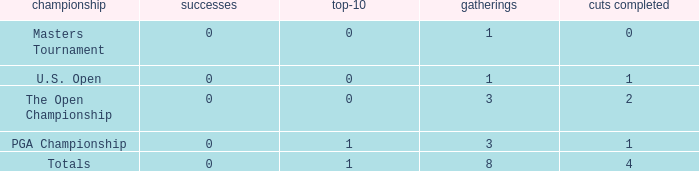For events with under 3 times played and fewer than 1 cut made, what is the total number of top-10 finishes? 1.0. 